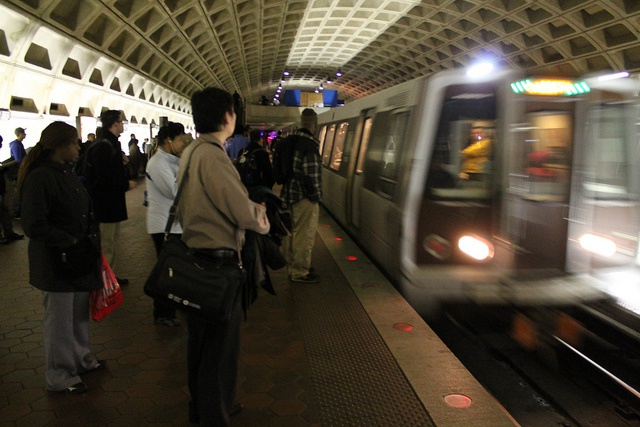Describe the objects in this image and their specific colors. I can see train in darkgreen, black, and gray tones, train in darkgreen, gray, white, and darkgray tones, people in darkgreen, black, and gray tones, people in darkgreen, black, and gray tones, and handbag in darkgreen, black, and gray tones in this image. 